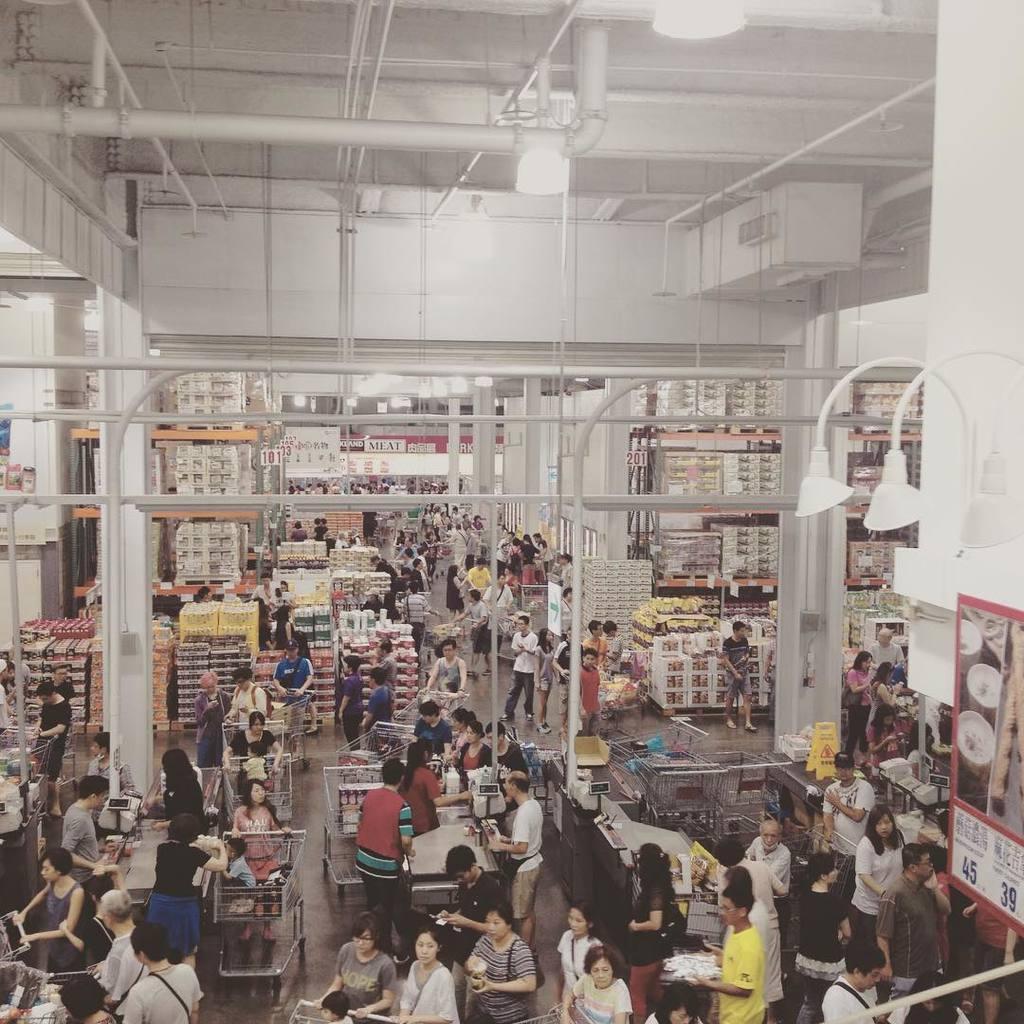How would you summarize this image in a sentence or two? Here in this picture we can see number of people standing on the floor and we can see this is a store, in which we can see number of things present in racks and we can see light posts present and we can see some pipes and other things present over there. 